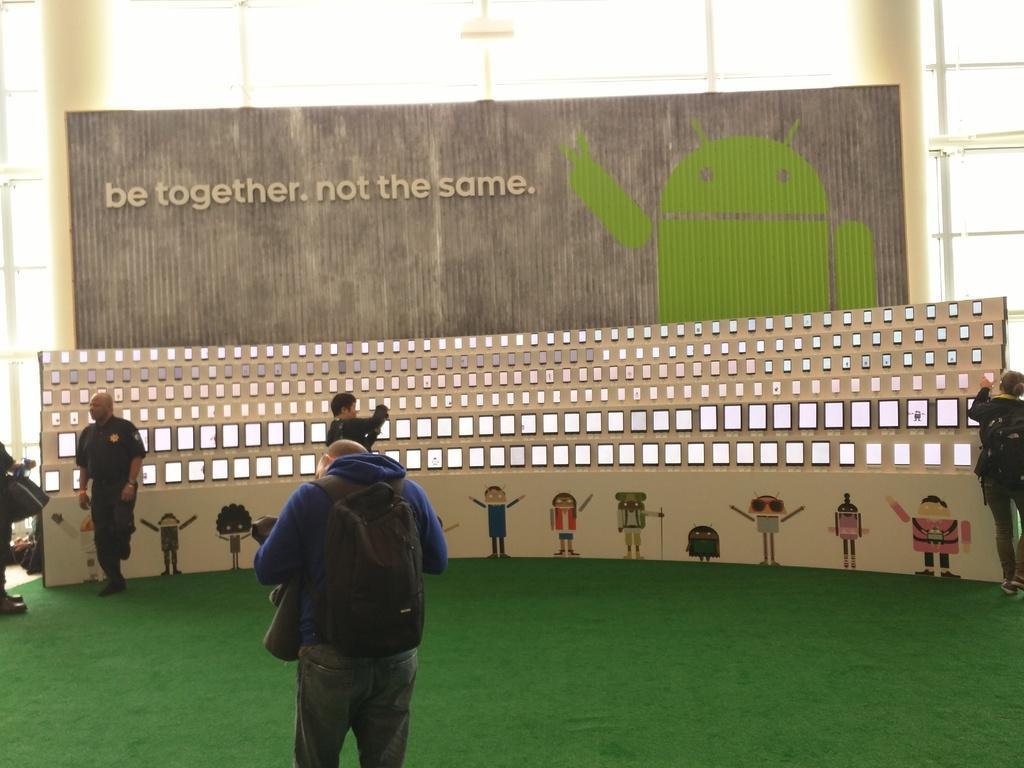Describe this image in one or two sentences. In this image I can see a person wearing a back pack visible in the foreground and I can see there are few persons visible in front of the fence and on the fence I can see cartoon image and text and small screens attached to the fence and I can see poles and glass window visible at the top. 